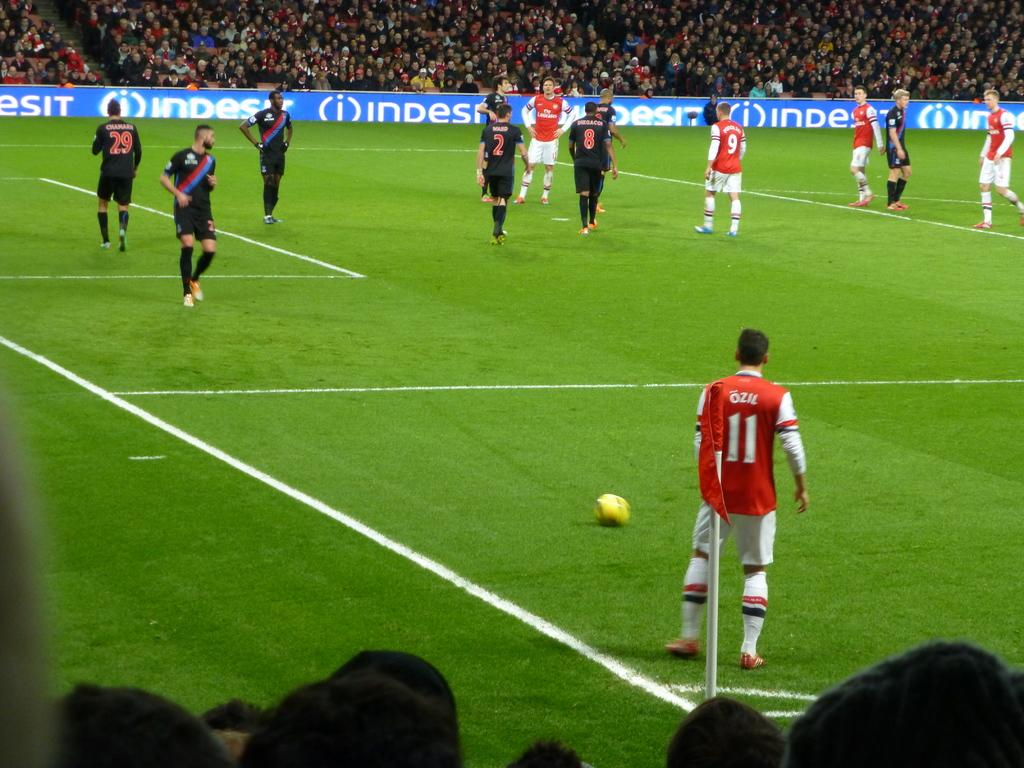<image>
Give a short and clear explanation of the subsequent image. A soccer match with players standing on the green in front of ads for INDESIT 